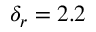<formula> <loc_0><loc_0><loc_500><loc_500>\delta _ { r } = 2 . 2</formula> 